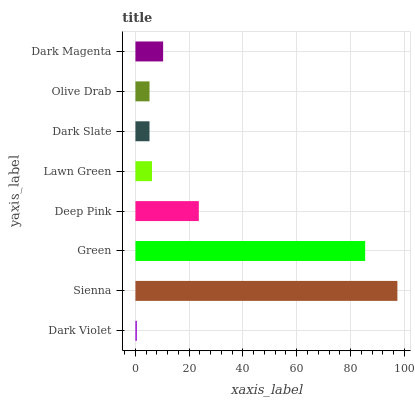Is Dark Violet the minimum?
Answer yes or no. Yes. Is Sienna the maximum?
Answer yes or no. Yes. Is Green the minimum?
Answer yes or no. No. Is Green the maximum?
Answer yes or no. No. Is Sienna greater than Green?
Answer yes or no. Yes. Is Green less than Sienna?
Answer yes or no. Yes. Is Green greater than Sienna?
Answer yes or no. No. Is Sienna less than Green?
Answer yes or no. No. Is Dark Magenta the high median?
Answer yes or no. Yes. Is Lawn Green the low median?
Answer yes or no. Yes. Is Dark Violet the high median?
Answer yes or no. No. Is Sienna the low median?
Answer yes or no. No. 